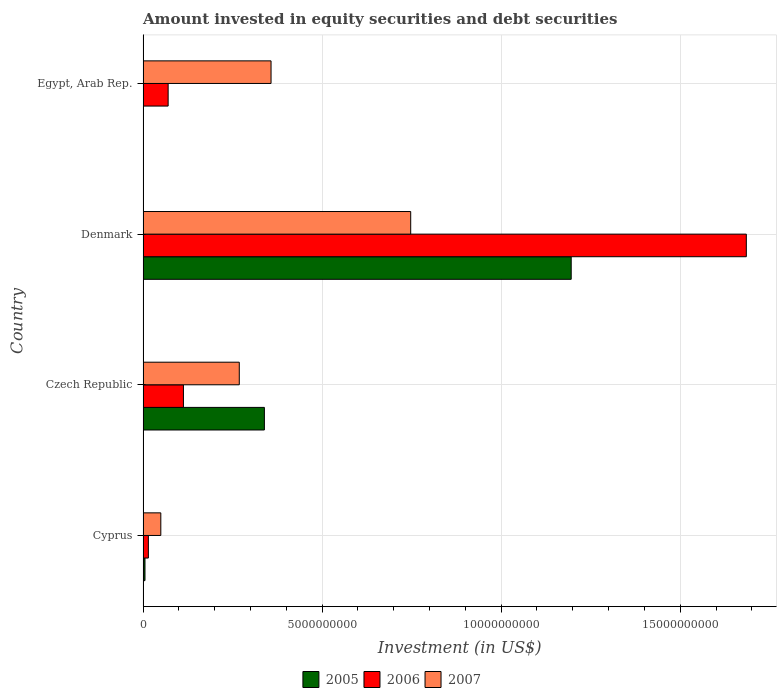How many groups of bars are there?
Your answer should be compact. 4. Are the number of bars on each tick of the Y-axis equal?
Your answer should be very brief. No. How many bars are there on the 2nd tick from the top?
Provide a short and direct response. 3. What is the label of the 1st group of bars from the top?
Make the answer very short. Egypt, Arab Rep. What is the amount invested in equity securities and debt securities in 2007 in Cyprus?
Offer a very short reply. 4.96e+08. Across all countries, what is the maximum amount invested in equity securities and debt securities in 2006?
Ensure brevity in your answer.  1.68e+1. Across all countries, what is the minimum amount invested in equity securities and debt securities in 2007?
Offer a terse response. 4.96e+08. In which country was the amount invested in equity securities and debt securities in 2005 maximum?
Provide a succinct answer. Denmark. What is the total amount invested in equity securities and debt securities in 2007 in the graph?
Offer a very short reply. 1.42e+1. What is the difference between the amount invested in equity securities and debt securities in 2007 in Czech Republic and that in Egypt, Arab Rep.?
Offer a very short reply. -8.87e+08. What is the difference between the amount invested in equity securities and debt securities in 2007 in Denmark and the amount invested in equity securities and debt securities in 2006 in Cyprus?
Ensure brevity in your answer.  7.33e+09. What is the average amount invested in equity securities and debt securities in 2006 per country?
Offer a terse response. 4.71e+09. What is the difference between the amount invested in equity securities and debt securities in 2006 and amount invested in equity securities and debt securities in 2007 in Denmark?
Keep it short and to the point. 9.37e+09. In how many countries, is the amount invested in equity securities and debt securities in 2007 greater than 9000000000 US$?
Give a very brief answer. 0. What is the ratio of the amount invested in equity securities and debt securities in 2006 in Cyprus to that in Czech Republic?
Provide a short and direct response. 0.13. Is the amount invested in equity securities and debt securities in 2005 in Cyprus less than that in Denmark?
Keep it short and to the point. Yes. Is the difference between the amount invested in equity securities and debt securities in 2006 in Cyprus and Czech Republic greater than the difference between the amount invested in equity securities and debt securities in 2007 in Cyprus and Czech Republic?
Keep it short and to the point. Yes. What is the difference between the highest and the second highest amount invested in equity securities and debt securities in 2005?
Offer a very short reply. 8.57e+09. What is the difference between the highest and the lowest amount invested in equity securities and debt securities in 2005?
Your response must be concise. 1.20e+1. In how many countries, is the amount invested in equity securities and debt securities in 2007 greater than the average amount invested in equity securities and debt securities in 2007 taken over all countries?
Offer a very short reply. 2. Is it the case that in every country, the sum of the amount invested in equity securities and debt securities in 2005 and amount invested in equity securities and debt securities in 2006 is greater than the amount invested in equity securities and debt securities in 2007?
Provide a short and direct response. No. How many bars are there?
Your answer should be very brief. 11. Are all the bars in the graph horizontal?
Make the answer very short. Yes. How many countries are there in the graph?
Your answer should be compact. 4. What is the difference between two consecutive major ticks on the X-axis?
Your answer should be very brief. 5.00e+09. Where does the legend appear in the graph?
Give a very brief answer. Bottom center. How are the legend labels stacked?
Offer a very short reply. Horizontal. What is the title of the graph?
Offer a very short reply. Amount invested in equity securities and debt securities. What is the label or title of the X-axis?
Provide a short and direct response. Investment (in US$). What is the label or title of the Y-axis?
Provide a short and direct response. Country. What is the Investment (in US$) of 2005 in Cyprus?
Ensure brevity in your answer.  5.37e+07. What is the Investment (in US$) of 2006 in Cyprus?
Ensure brevity in your answer.  1.48e+08. What is the Investment (in US$) in 2007 in Cyprus?
Give a very brief answer. 4.96e+08. What is the Investment (in US$) in 2005 in Czech Republic?
Your response must be concise. 3.39e+09. What is the Investment (in US$) in 2006 in Czech Republic?
Your response must be concise. 1.13e+09. What is the Investment (in US$) in 2007 in Czech Republic?
Provide a short and direct response. 2.69e+09. What is the Investment (in US$) in 2005 in Denmark?
Your response must be concise. 1.20e+1. What is the Investment (in US$) of 2006 in Denmark?
Provide a succinct answer. 1.68e+1. What is the Investment (in US$) in 2007 in Denmark?
Give a very brief answer. 7.47e+09. What is the Investment (in US$) of 2006 in Egypt, Arab Rep.?
Give a very brief answer. 7.00e+08. What is the Investment (in US$) of 2007 in Egypt, Arab Rep.?
Offer a very short reply. 3.57e+09. Across all countries, what is the maximum Investment (in US$) of 2005?
Your answer should be compact. 1.20e+1. Across all countries, what is the maximum Investment (in US$) of 2006?
Provide a short and direct response. 1.68e+1. Across all countries, what is the maximum Investment (in US$) of 2007?
Provide a short and direct response. 7.47e+09. Across all countries, what is the minimum Investment (in US$) in 2006?
Your answer should be very brief. 1.48e+08. Across all countries, what is the minimum Investment (in US$) in 2007?
Your answer should be very brief. 4.96e+08. What is the total Investment (in US$) of 2005 in the graph?
Ensure brevity in your answer.  1.54e+1. What is the total Investment (in US$) in 2006 in the graph?
Make the answer very short. 1.88e+1. What is the total Investment (in US$) in 2007 in the graph?
Your response must be concise. 1.42e+1. What is the difference between the Investment (in US$) of 2005 in Cyprus and that in Czech Republic?
Your answer should be very brief. -3.33e+09. What is the difference between the Investment (in US$) in 2006 in Cyprus and that in Czech Republic?
Your response must be concise. -9.79e+08. What is the difference between the Investment (in US$) of 2007 in Cyprus and that in Czech Republic?
Keep it short and to the point. -2.19e+09. What is the difference between the Investment (in US$) of 2005 in Cyprus and that in Denmark?
Offer a very short reply. -1.19e+1. What is the difference between the Investment (in US$) of 2006 in Cyprus and that in Denmark?
Your answer should be very brief. -1.67e+1. What is the difference between the Investment (in US$) of 2007 in Cyprus and that in Denmark?
Your response must be concise. -6.98e+09. What is the difference between the Investment (in US$) of 2006 in Cyprus and that in Egypt, Arab Rep.?
Ensure brevity in your answer.  -5.52e+08. What is the difference between the Investment (in US$) in 2007 in Cyprus and that in Egypt, Arab Rep.?
Offer a terse response. -3.08e+09. What is the difference between the Investment (in US$) of 2005 in Czech Republic and that in Denmark?
Keep it short and to the point. -8.57e+09. What is the difference between the Investment (in US$) in 2006 in Czech Republic and that in Denmark?
Offer a very short reply. -1.57e+1. What is the difference between the Investment (in US$) of 2007 in Czech Republic and that in Denmark?
Offer a very short reply. -4.79e+09. What is the difference between the Investment (in US$) in 2006 in Czech Republic and that in Egypt, Arab Rep.?
Make the answer very short. 4.27e+08. What is the difference between the Investment (in US$) in 2007 in Czech Republic and that in Egypt, Arab Rep.?
Ensure brevity in your answer.  -8.87e+08. What is the difference between the Investment (in US$) of 2006 in Denmark and that in Egypt, Arab Rep.?
Your answer should be compact. 1.61e+1. What is the difference between the Investment (in US$) of 2007 in Denmark and that in Egypt, Arab Rep.?
Your response must be concise. 3.90e+09. What is the difference between the Investment (in US$) in 2005 in Cyprus and the Investment (in US$) in 2006 in Czech Republic?
Make the answer very short. -1.07e+09. What is the difference between the Investment (in US$) of 2005 in Cyprus and the Investment (in US$) of 2007 in Czech Republic?
Offer a very short reply. -2.63e+09. What is the difference between the Investment (in US$) of 2006 in Cyprus and the Investment (in US$) of 2007 in Czech Republic?
Provide a succinct answer. -2.54e+09. What is the difference between the Investment (in US$) in 2005 in Cyprus and the Investment (in US$) in 2006 in Denmark?
Give a very brief answer. -1.68e+1. What is the difference between the Investment (in US$) in 2005 in Cyprus and the Investment (in US$) in 2007 in Denmark?
Provide a succinct answer. -7.42e+09. What is the difference between the Investment (in US$) of 2006 in Cyprus and the Investment (in US$) of 2007 in Denmark?
Keep it short and to the point. -7.33e+09. What is the difference between the Investment (in US$) in 2005 in Cyprus and the Investment (in US$) in 2006 in Egypt, Arab Rep.?
Offer a terse response. -6.47e+08. What is the difference between the Investment (in US$) in 2005 in Cyprus and the Investment (in US$) in 2007 in Egypt, Arab Rep.?
Offer a terse response. -3.52e+09. What is the difference between the Investment (in US$) of 2006 in Cyprus and the Investment (in US$) of 2007 in Egypt, Arab Rep.?
Keep it short and to the point. -3.43e+09. What is the difference between the Investment (in US$) of 2005 in Czech Republic and the Investment (in US$) of 2006 in Denmark?
Make the answer very short. -1.35e+1. What is the difference between the Investment (in US$) of 2005 in Czech Republic and the Investment (in US$) of 2007 in Denmark?
Offer a very short reply. -4.09e+09. What is the difference between the Investment (in US$) in 2006 in Czech Republic and the Investment (in US$) in 2007 in Denmark?
Provide a succinct answer. -6.35e+09. What is the difference between the Investment (in US$) in 2005 in Czech Republic and the Investment (in US$) in 2006 in Egypt, Arab Rep.?
Keep it short and to the point. 2.69e+09. What is the difference between the Investment (in US$) of 2005 in Czech Republic and the Investment (in US$) of 2007 in Egypt, Arab Rep.?
Make the answer very short. -1.86e+08. What is the difference between the Investment (in US$) in 2006 in Czech Republic and the Investment (in US$) in 2007 in Egypt, Arab Rep.?
Your response must be concise. -2.45e+09. What is the difference between the Investment (in US$) in 2005 in Denmark and the Investment (in US$) in 2006 in Egypt, Arab Rep.?
Provide a short and direct response. 1.13e+1. What is the difference between the Investment (in US$) in 2005 in Denmark and the Investment (in US$) in 2007 in Egypt, Arab Rep.?
Your response must be concise. 8.38e+09. What is the difference between the Investment (in US$) in 2006 in Denmark and the Investment (in US$) in 2007 in Egypt, Arab Rep.?
Provide a succinct answer. 1.33e+1. What is the average Investment (in US$) in 2005 per country?
Your response must be concise. 3.85e+09. What is the average Investment (in US$) of 2006 per country?
Provide a short and direct response. 4.71e+09. What is the average Investment (in US$) of 2007 per country?
Provide a succinct answer. 3.56e+09. What is the difference between the Investment (in US$) in 2005 and Investment (in US$) in 2006 in Cyprus?
Ensure brevity in your answer.  -9.46e+07. What is the difference between the Investment (in US$) of 2005 and Investment (in US$) of 2007 in Cyprus?
Offer a very short reply. -4.42e+08. What is the difference between the Investment (in US$) of 2006 and Investment (in US$) of 2007 in Cyprus?
Your answer should be very brief. -3.47e+08. What is the difference between the Investment (in US$) in 2005 and Investment (in US$) in 2006 in Czech Republic?
Your response must be concise. 2.26e+09. What is the difference between the Investment (in US$) in 2005 and Investment (in US$) in 2007 in Czech Republic?
Ensure brevity in your answer.  7.01e+08. What is the difference between the Investment (in US$) in 2006 and Investment (in US$) in 2007 in Czech Republic?
Keep it short and to the point. -1.56e+09. What is the difference between the Investment (in US$) of 2005 and Investment (in US$) of 2006 in Denmark?
Make the answer very short. -4.89e+09. What is the difference between the Investment (in US$) in 2005 and Investment (in US$) in 2007 in Denmark?
Provide a short and direct response. 4.48e+09. What is the difference between the Investment (in US$) of 2006 and Investment (in US$) of 2007 in Denmark?
Keep it short and to the point. 9.37e+09. What is the difference between the Investment (in US$) of 2006 and Investment (in US$) of 2007 in Egypt, Arab Rep.?
Give a very brief answer. -2.87e+09. What is the ratio of the Investment (in US$) of 2005 in Cyprus to that in Czech Republic?
Keep it short and to the point. 0.02. What is the ratio of the Investment (in US$) of 2006 in Cyprus to that in Czech Republic?
Keep it short and to the point. 0.13. What is the ratio of the Investment (in US$) of 2007 in Cyprus to that in Czech Republic?
Your response must be concise. 0.18. What is the ratio of the Investment (in US$) in 2005 in Cyprus to that in Denmark?
Your answer should be very brief. 0. What is the ratio of the Investment (in US$) in 2006 in Cyprus to that in Denmark?
Your response must be concise. 0.01. What is the ratio of the Investment (in US$) in 2007 in Cyprus to that in Denmark?
Offer a very short reply. 0.07. What is the ratio of the Investment (in US$) in 2006 in Cyprus to that in Egypt, Arab Rep.?
Provide a succinct answer. 0.21. What is the ratio of the Investment (in US$) of 2007 in Cyprus to that in Egypt, Arab Rep.?
Offer a terse response. 0.14. What is the ratio of the Investment (in US$) of 2005 in Czech Republic to that in Denmark?
Ensure brevity in your answer.  0.28. What is the ratio of the Investment (in US$) of 2006 in Czech Republic to that in Denmark?
Offer a terse response. 0.07. What is the ratio of the Investment (in US$) of 2007 in Czech Republic to that in Denmark?
Provide a succinct answer. 0.36. What is the ratio of the Investment (in US$) of 2006 in Czech Republic to that in Egypt, Arab Rep.?
Offer a very short reply. 1.61. What is the ratio of the Investment (in US$) in 2007 in Czech Republic to that in Egypt, Arab Rep.?
Provide a short and direct response. 0.75. What is the ratio of the Investment (in US$) of 2006 in Denmark to that in Egypt, Arab Rep.?
Ensure brevity in your answer.  24.05. What is the ratio of the Investment (in US$) of 2007 in Denmark to that in Egypt, Arab Rep.?
Your response must be concise. 2.09. What is the difference between the highest and the second highest Investment (in US$) of 2005?
Offer a very short reply. 8.57e+09. What is the difference between the highest and the second highest Investment (in US$) in 2006?
Provide a short and direct response. 1.57e+1. What is the difference between the highest and the second highest Investment (in US$) of 2007?
Your response must be concise. 3.90e+09. What is the difference between the highest and the lowest Investment (in US$) in 2005?
Provide a short and direct response. 1.20e+1. What is the difference between the highest and the lowest Investment (in US$) in 2006?
Your answer should be very brief. 1.67e+1. What is the difference between the highest and the lowest Investment (in US$) of 2007?
Provide a short and direct response. 6.98e+09. 